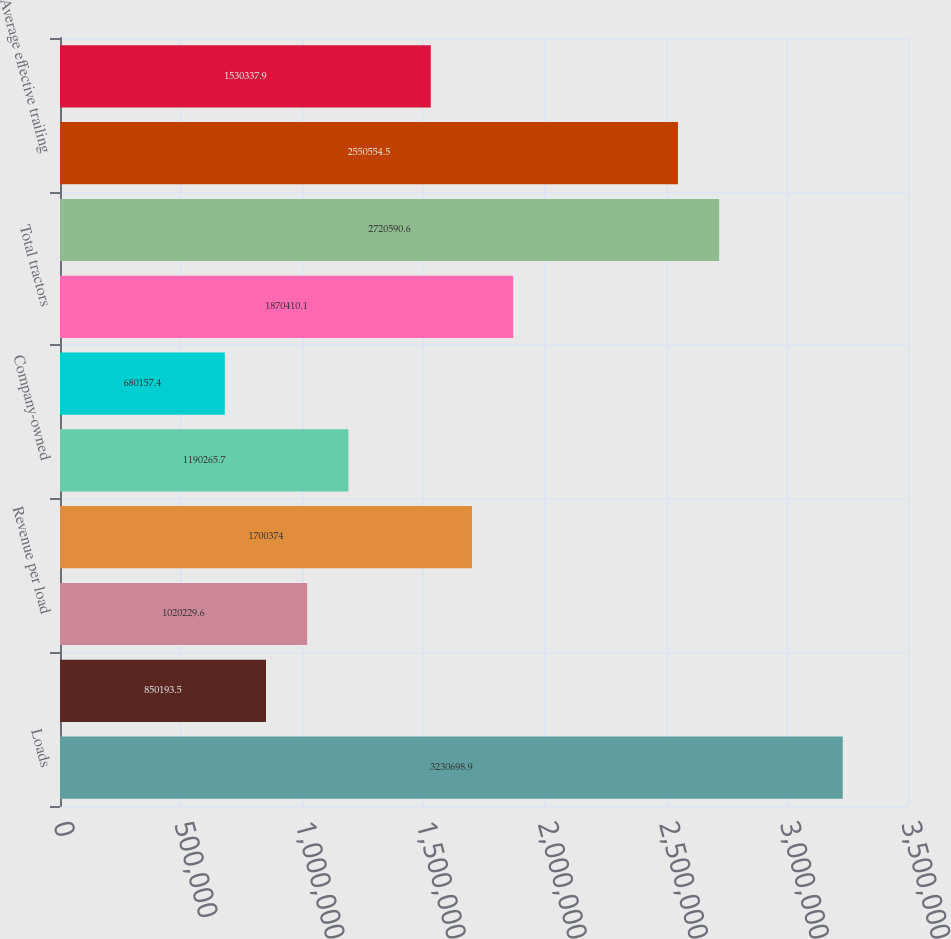<chart> <loc_0><loc_0><loc_500><loc_500><bar_chart><fcel>Loads<fcel>Average length of haul (miles)<fcel>Revenue per load<fcel>Average tractors during the<fcel>Company-owned<fcel>Independent contractor<fcel>Total tractors<fcel>Trailing equipment (end of<fcel>Average effective trailing<fcel>Revenue per truck per week (2)<nl><fcel>3.2307e+06<fcel>850194<fcel>1.02023e+06<fcel>1.70037e+06<fcel>1.19027e+06<fcel>680157<fcel>1.87041e+06<fcel>2.72059e+06<fcel>2.55055e+06<fcel>1.53034e+06<nl></chart> 